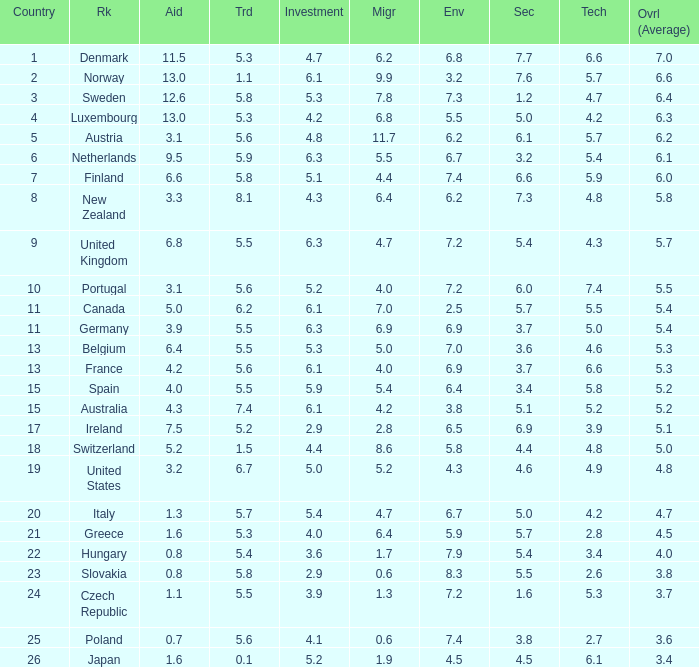What country has a 5.5 mark for security? Slovakia. 